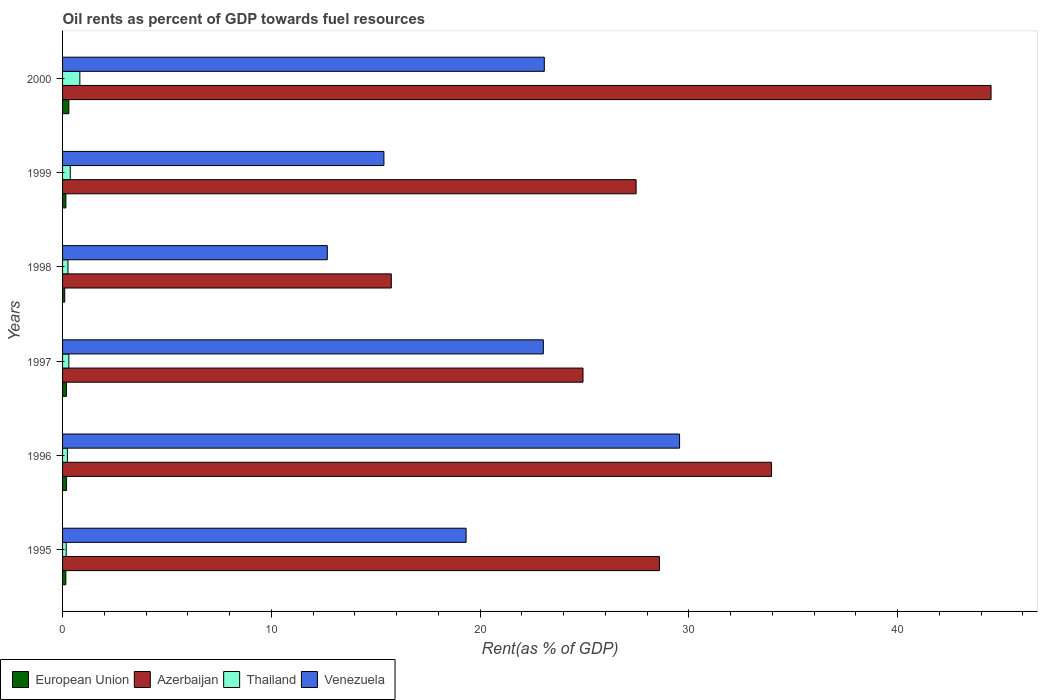How many different coloured bars are there?
Your answer should be compact. 4. How many bars are there on the 4th tick from the bottom?
Your answer should be very brief. 4. What is the label of the 6th group of bars from the top?
Keep it short and to the point. 1995. In how many cases, is the number of bars for a given year not equal to the number of legend labels?
Give a very brief answer. 0. What is the oil rent in European Union in 1997?
Offer a terse response. 0.19. Across all years, what is the maximum oil rent in Venezuela?
Offer a terse response. 29.55. Across all years, what is the minimum oil rent in Venezuela?
Provide a short and direct response. 12.68. In which year was the oil rent in Venezuela minimum?
Give a very brief answer. 1998. What is the total oil rent in Thailand in the graph?
Your answer should be compact. 2.16. What is the difference between the oil rent in Venezuela in 1996 and that in 2000?
Ensure brevity in your answer.  6.48. What is the difference between the oil rent in Venezuela in 2000 and the oil rent in Thailand in 1995?
Ensure brevity in your answer.  22.9. What is the average oil rent in Venezuela per year?
Offer a very short reply. 20.51. In the year 1996, what is the difference between the oil rent in Azerbaijan and oil rent in European Union?
Your answer should be very brief. 33.77. What is the ratio of the oil rent in Thailand in 1997 to that in 1999?
Give a very brief answer. 0.82. Is the oil rent in Azerbaijan in 1996 less than that in 1997?
Provide a succinct answer. No. Is the difference between the oil rent in Azerbaijan in 1995 and 1996 greater than the difference between the oil rent in European Union in 1995 and 1996?
Your answer should be compact. No. What is the difference between the highest and the second highest oil rent in Venezuela?
Give a very brief answer. 6.48. What is the difference between the highest and the lowest oil rent in European Union?
Your answer should be very brief. 0.2. Is it the case that in every year, the sum of the oil rent in Azerbaijan and oil rent in European Union is greater than the sum of oil rent in Venezuela and oil rent in Thailand?
Ensure brevity in your answer.  Yes. What does the 3rd bar from the top in 1999 represents?
Your answer should be compact. Azerbaijan. What does the 1st bar from the bottom in 1997 represents?
Provide a succinct answer. European Union. Is it the case that in every year, the sum of the oil rent in European Union and oil rent in Venezuela is greater than the oil rent in Thailand?
Your answer should be very brief. Yes. Are all the bars in the graph horizontal?
Keep it short and to the point. Yes. How many years are there in the graph?
Make the answer very short. 6. What is the difference between two consecutive major ticks on the X-axis?
Ensure brevity in your answer.  10. Are the values on the major ticks of X-axis written in scientific E-notation?
Ensure brevity in your answer.  No. Where does the legend appear in the graph?
Make the answer very short. Bottom left. What is the title of the graph?
Keep it short and to the point. Oil rents as percent of GDP towards fuel resources. Does "Fragile and conflict affected situations" appear as one of the legend labels in the graph?
Give a very brief answer. No. What is the label or title of the X-axis?
Provide a short and direct response. Rent(as % of GDP). What is the Rent(as % of GDP) in European Union in 1995?
Provide a succinct answer. 0.16. What is the Rent(as % of GDP) of Azerbaijan in 1995?
Offer a very short reply. 28.59. What is the Rent(as % of GDP) in Thailand in 1995?
Offer a terse response. 0.18. What is the Rent(as % of GDP) of Venezuela in 1995?
Your response must be concise. 19.33. What is the Rent(as % of GDP) of European Union in 1996?
Give a very brief answer. 0.19. What is the Rent(as % of GDP) in Azerbaijan in 1996?
Your answer should be compact. 33.96. What is the Rent(as % of GDP) of Thailand in 1996?
Your answer should be very brief. 0.23. What is the Rent(as % of GDP) in Venezuela in 1996?
Your answer should be very brief. 29.55. What is the Rent(as % of GDP) in European Union in 1997?
Give a very brief answer. 0.19. What is the Rent(as % of GDP) in Azerbaijan in 1997?
Provide a short and direct response. 24.93. What is the Rent(as % of GDP) of Thailand in 1997?
Ensure brevity in your answer.  0.3. What is the Rent(as % of GDP) of Venezuela in 1997?
Your answer should be very brief. 23.03. What is the Rent(as % of GDP) of European Union in 1998?
Offer a terse response. 0.1. What is the Rent(as % of GDP) in Azerbaijan in 1998?
Your answer should be very brief. 15.75. What is the Rent(as % of GDP) in Thailand in 1998?
Give a very brief answer. 0.26. What is the Rent(as % of GDP) in Venezuela in 1998?
Offer a very short reply. 12.68. What is the Rent(as % of GDP) in European Union in 1999?
Provide a succinct answer. 0.16. What is the Rent(as % of GDP) in Azerbaijan in 1999?
Provide a short and direct response. 27.47. What is the Rent(as % of GDP) of Thailand in 1999?
Provide a short and direct response. 0.37. What is the Rent(as % of GDP) in Venezuela in 1999?
Offer a very short reply. 15.39. What is the Rent(as % of GDP) in European Union in 2000?
Provide a succinct answer. 0.3. What is the Rent(as % of GDP) in Azerbaijan in 2000?
Keep it short and to the point. 44.47. What is the Rent(as % of GDP) of Thailand in 2000?
Ensure brevity in your answer.  0.83. What is the Rent(as % of GDP) in Venezuela in 2000?
Your answer should be compact. 23.07. Across all years, what is the maximum Rent(as % of GDP) in European Union?
Keep it short and to the point. 0.3. Across all years, what is the maximum Rent(as % of GDP) in Azerbaijan?
Keep it short and to the point. 44.47. Across all years, what is the maximum Rent(as % of GDP) of Thailand?
Your answer should be very brief. 0.83. Across all years, what is the maximum Rent(as % of GDP) of Venezuela?
Your answer should be very brief. 29.55. Across all years, what is the minimum Rent(as % of GDP) in European Union?
Offer a very short reply. 0.1. Across all years, what is the minimum Rent(as % of GDP) in Azerbaijan?
Ensure brevity in your answer.  15.75. Across all years, what is the minimum Rent(as % of GDP) in Thailand?
Offer a very short reply. 0.18. Across all years, what is the minimum Rent(as % of GDP) of Venezuela?
Your response must be concise. 12.68. What is the total Rent(as % of GDP) of European Union in the graph?
Offer a very short reply. 1.1. What is the total Rent(as % of GDP) of Azerbaijan in the graph?
Provide a short and direct response. 175.17. What is the total Rent(as % of GDP) in Thailand in the graph?
Give a very brief answer. 2.16. What is the total Rent(as % of GDP) of Venezuela in the graph?
Ensure brevity in your answer.  123.06. What is the difference between the Rent(as % of GDP) of European Union in 1995 and that in 1996?
Keep it short and to the point. -0.03. What is the difference between the Rent(as % of GDP) in Azerbaijan in 1995 and that in 1996?
Provide a short and direct response. -5.37. What is the difference between the Rent(as % of GDP) in Thailand in 1995 and that in 1996?
Ensure brevity in your answer.  -0.05. What is the difference between the Rent(as % of GDP) of Venezuela in 1995 and that in 1996?
Keep it short and to the point. -10.23. What is the difference between the Rent(as % of GDP) in European Union in 1995 and that in 1997?
Give a very brief answer. -0.03. What is the difference between the Rent(as % of GDP) in Azerbaijan in 1995 and that in 1997?
Provide a succinct answer. 3.66. What is the difference between the Rent(as % of GDP) in Thailand in 1995 and that in 1997?
Provide a succinct answer. -0.13. What is the difference between the Rent(as % of GDP) in Venezuela in 1995 and that in 1997?
Provide a short and direct response. -3.7. What is the difference between the Rent(as % of GDP) in European Union in 1995 and that in 1998?
Your answer should be compact. 0.05. What is the difference between the Rent(as % of GDP) of Azerbaijan in 1995 and that in 1998?
Offer a terse response. 12.84. What is the difference between the Rent(as % of GDP) in Thailand in 1995 and that in 1998?
Your answer should be compact. -0.08. What is the difference between the Rent(as % of GDP) of Venezuela in 1995 and that in 1998?
Provide a succinct answer. 6.65. What is the difference between the Rent(as % of GDP) in European Union in 1995 and that in 1999?
Provide a succinct answer. -0. What is the difference between the Rent(as % of GDP) of Azerbaijan in 1995 and that in 1999?
Your answer should be compact. 1.12. What is the difference between the Rent(as % of GDP) of Thailand in 1995 and that in 1999?
Give a very brief answer. -0.19. What is the difference between the Rent(as % of GDP) of Venezuela in 1995 and that in 1999?
Offer a very short reply. 3.94. What is the difference between the Rent(as % of GDP) in European Union in 1995 and that in 2000?
Your answer should be compact. -0.14. What is the difference between the Rent(as % of GDP) of Azerbaijan in 1995 and that in 2000?
Ensure brevity in your answer.  -15.89. What is the difference between the Rent(as % of GDP) in Thailand in 1995 and that in 2000?
Make the answer very short. -0.65. What is the difference between the Rent(as % of GDP) of Venezuela in 1995 and that in 2000?
Make the answer very short. -3.75. What is the difference between the Rent(as % of GDP) of European Union in 1996 and that in 1997?
Keep it short and to the point. 0. What is the difference between the Rent(as % of GDP) of Azerbaijan in 1996 and that in 1997?
Your answer should be very brief. 9.03. What is the difference between the Rent(as % of GDP) in Thailand in 1996 and that in 1997?
Your answer should be compact. -0.07. What is the difference between the Rent(as % of GDP) of Venezuela in 1996 and that in 1997?
Your answer should be very brief. 6.53. What is the difference between the Rent(as % of GDP) in European Union in 1996 and that in 1998?
Provide a short and direct response. 0.09. What is the difference between the Rent(as % of GDP) of Azerbaijan in 1996 and that in 1998?
Give a very brief answer. 18.21. What is the difference between the Rent(as % of GDP) in Thailand in 1996 and that in 1998?
Your response must be concise. -0.03. What is the difference between the Rent(as % of GDP) of Venezuela in 1996 and that in 1998?
Give a very brief answer. 16.87. What is the difference between the Rent(as % of GDP) of European Union in 1996 and that in 1999?
Offer a very short reply. 0.03. What is the difference between the Rent(as % of GDP) of Azerbaijan in 1996 and that in 1999?
Your response must be concise. 6.49. What is the difference between the Rent(as % of GDP) in Thailand in 1996 and that in 1999?
Offer a very short reply. -0.14. What is the difference between the Rent(as % of GDP) in Venezuela in 1996 and that in 1999?
Make the answer very short. 14.16. What is the difference between the Rent(as % of GDP) in European Union in 1996 and that in 2000?
Keep it short and to the point. -0.11. What is the difference between the Rent(as % of GDP) in Azerbaijan in 1996 and that in 2000?
Provide a short and direct response. -10.52. What is the difference between the Rent(as % of GDP) in Thailand in 1996 and that in 2000?
Keep it short and to the point. -0.6. What is the difference between the Rent(as % of GDP) in Venezuela in 1996 and that in 2000?
Provide a short and direct response. 6.48. What is the difference between the Rent(as % of GDP) in European Union in 1997 and that in 1998?
Ensure brevity in your answer.  0.08. What is the difference between the Rent(as % of GDP) in Azerbaijan in 1997 and that in 1998?
Ensure brevity in your answer.  9.18. What is the difference between the Rent(as % of GDP) in Thailand in 1997 and that in 1998?
Give a very brief answer. 0.04. What is the difference between the Rent(as % of GDP) of Venezuela in 1997 and that in 1998?
Your response must be concise. 10.35. What is the difference between the Rent(as % of GDP) of European Union in 1997 and that in 1999?
Give a very brief answer. 0.03. What is the difference between the Rent(as % of GDP) of Azerbaijan in 1997 and that in 1999?
Give a very brief answer. -2.54. What is the difference between the Rent(as % of GDP) of Thailand in 1997 and that in 1999?
Your answer should be compact. -0.07. What is the difference between the Rent(as % of GDP) of Venezuela in 1997 and that in 1999?
Provide a short and direct response. 7.64. What is the difference between the Rent(as % of GDP) of European Union in 1997 and that in 2000?
Make the answer very short. -0.11. What is the difference between the Rent(as % of GDP) of Azerbaijan in 1997 and that in 2000?
Offer a very short reply. -19.55. What is the difference between the Rent(as % of GDP) of Thailand in 1997 and that in 2000?
Your response must be concise. -0.53. What is the difference between the Rent(as % of GDP) in Venezuela in 1997 and that in 2000?
Offer a very short reply. -0.05. What is the difference between the Rent(as % of GDP) in European Union in 1998 and that in 1999?
Your response must be concise. -0.06. What is the difference between the Rent(as % of GDP) of Azerbaijan in 1998 and that in 1999?
Ensure brevity in your answer.  -11.73. What is the difference between the Rent(as % of GDP) of Thailand in 1998 and that in 1999?
Make the answer very short. -0.11. What is the difference between the Rent(as % of GDP) of Venezuela in 1998 and that in 1999?
Make the answer very short. -2.71. What is the difference between the Rent(as % of GDP) of European Union in 1998 and that in 2000?
Your answer should be very brief. -0.2. What is the difference between the Rent(as % of GDP) of Azerbaijan in 1998 and that in 2000?
Offer a terse response. -28.73. What is the difference between the Rent(as % of GDP) of Thailand in 1998 and that in 2000?
Your response must be concise. -0.57. What is the difference between the Rent(as % of GDP) in Venezuela in 1998 and that in 2000?
Provide a short and direct response. -10.39. What is the difference between the Rent(as % of GDP) in European Union in 1999 and that in 2000?
Make the answer very short. -0.14. What is the difference between the Rent(as % of GDP) of Azerbaijan in 1999 and that in 2000?
Your answer should be compact. -17. What is the difference between the Rent(as % of GDP) in Thailand in 1999 and that in 2000?
Offer a terse response. -0.46. What is the difference between the Rent(as % of GDP) in Venezuela in 1999 and that in 2000?
Your answer should be compact. -7.68. What is the difference between the Rent(as % of GDP) in European Union in 1995 and the Rent(as % of GDP) in Azerbaijan in 1996?
Offer a terse response. -33.8. What is the difference between the Rent(as % of GDP) in European Union in 1995 and the Rent(as % of GDP) in Thailand in 1996?
Make the answer very short. -0.07. What is the difference between the Rent(as % of GDP) of European Union in 1995 and the Rent(as % of GDP) of Venezuela in 1996?
Make the answer very short. -29.4. What is the difference between the Rent(as % of GDP) of Azerbaijan in 1995 and the Rent(as % of GDP) of Thailand in 1996?
Offer a terse response. 28.36. What is the difference between the Rent(as % of GDP) in Azerbaijan in 1995 and the Rent(as % of GDP) in Venezuela in 1996?
Give a very brief answer. -0.97. What is the difference between the Rent(as % of GDP) in Thailand in 1995 and the Rent(as % of GDP) in Venezuela in 1996?
Offer a very short reply. -29.38. What is the difference between the Rent(as % of GDP) of European Union in 1995 and the Rent(as % of GDP) of Azerbaijan in 1997?
Ensure brevity in your answer.  -24.77. What is the difference between the Rent(as % of GDP) in European Union in 1995 and the Rent(as % of GDP) in Thailand in 1997?
Give a very brief answer. -0.14. What is the difference between the Rent(as % of GDP) in European Union in 1995 and the Rent(as % of GDP) in Venezuela in 1997?
Provide a succinct answer. -22.87. What is the difference between the Rent(as % of GDP) in Azerbaijan in 1995 and the Rent(as % of GDP) in Thailand in 1997?
Your answer should be very brief. 28.29. What is the difference between the Rent(as % of GDP) in Azerbaijan in 1995 and the Rent(as % of GDP) in Venezuela in 1997?
Your response must be concise. 5.56. What is the difference between the Rent(as % of GDP) in Thailand in 1995 and the Rent(as % of GDP) in Venezuela in 1997?
Ensure brevity in your answer.  -22.85. What is the difference between the Rent(as % of GDP) of European Union in 1995 and the Rent(as % of GDP) of Azerbaijan in 1998?
Keep it short and to the point. -15.59. What is the difference between the Rent(as % of GDP) in European Union in 1995 and the Rent(as % of GDP) in Thailand in 1998?
Make the answer very short. -0.1. What is the difference between the Rent(as % of GDP) of European Union in 1995 and the Rent(as % of GDP) of Venezuela in 1998?
Give a very brief answer. -12.52. What is the difference between the Rent(as % of GDP) in Azerbaijan in 1995 and the Rent(as % of GDP) in Thailand in 1998?
Offer a very short reply. 28.33. What is the difference between the Rent(as % of GDP) in Azerbaijan in 1995 and the Rent(as % of GDP) in Venezuela in 1998?
Give a very brief answer. 15.91. What is the difference between the Rent(as % of GDP) of Thailand in 1995 and the Rent(as % of GDP) of Venezuela in 1998?
Your response must be concise. -12.51. What is the difference between the Rent(as % of GDP) in European Union in 1995 and the Rent(as % of GDP) in Azerbaijan in 1999?
Your answer should be compact. -27.32. What is the difference between the Rent(as % of GDP) of European Union in 1995 and the Rent(as % of GDP) of Thailand in 1999?
Provide a short and direct response. -0.21. What is the difference between the Rent(as % of GDP) of European Union in 1995 and the Rent(as % of GDP) of Venezuela in 1999?
Make the answer very short. -15.23. What is the difference between the Rent(as % of GDP) in Azerbaijan in 1995 and the Rent(as % of GDP) in Thailand in 1999?
Your answer should be compact. 28.22. What is the difference between the Rent(as % of GDP) in Azerbaijan in 1995 and the Rent(as % of GDP) in Venezuela in 1999?
Ensure brevity in your answer.  13.2. What is the difference between the Rent(as % of GDP) in Thailand in 1995 and the Rent(as % of GDP) in Venezuela in 1999?
Your answer should be very brief. -15.22. What is the difference between the Rent(as % of GDP) in European Union in 1995 and the Rent(as % of GDP) in Azerbaijan in 2000?
Give a very brief answer. -44.32. What is the difference between the Rent(as % of GDP) of European Union in 1995 and the Rent(as % of GDP) of Thailand in 2000?
Provide a succinct answer. -0.67. What is the difference between the Rent(as % of GDP) in European Union in 1995 and the Rent(as % of GDP) in Venezuela in 2000?
Offer a very short reply. -22.92. What is the difference between the Rent(as % of GDP) in Azerbaijan in 1995 and the Rent(as % of GDP) in Thailand in 2000?
Your answer should be very brief. 27.76. What is the difference between the Rent(as % of GDP) in Azerbaijan in 1995 and the Rent(as % of GDP) in Venezuela in 2000?
Ensure brevity in your answer.  5.51. What is the difference between the Rent(as % of GDP) in Thailand in 1995 and the Rent(as % of GDP) in Venezuela in 2000?
Provide a succinct answer. -22.9. What is the difference between the Rent(as % of GDP) of European Union in 1996 and the Rent(as % of GDP) of Azerbaijan in 1997?
Your response must be concise. -24.74. What is the difference between the Rent(as % of GDP) in European Union in 1996 and the Rent(as % of GDP) in Thailand in 1997?
Offer a terse response. -0.11. What is the difference between the Rent(as % of GDP) in European Union in 1996 and the Rent(as % of GDP) in Venezuela in 1997?
Ensure brevity in your answer.  -22.84. What is the difference between the Rent(as % of GDP) in Azerbaijan in 1996 and the Rent(as % of GDP) in Thailand in 1997?
Your answer should be very brief. 33.66. What is the difference between the Rent(as % of GDP) of Azerbaijan in 1996 and the Rent(as % of GDP) of Venezuela in 1997?
Your answer should be very brief. 10.93. What is the difference between the Rent(as % of GDP) of Thailand in 1996 and the Rent(as % of GDP) of Venezuela in 1997?
Your answer should be very brief. -22.8. What is the difference between the Rent(as % of GDP) of European Union in 1996 and the Rent(as % of GDP) of Azerbaijan in 1998?
Provide a short and direct response. -15.56. What is the difference between the Rent(as % of GDP) in European Union in 1996 and the Rent(as % of GDP) in Thailand in 1998?
Provide a short and direct response. -0.07. What is the difference between the Rent(as % of GDP) of European Union in 1996 and the Rent(as % of GDP) of Venezuela in 1998?
Give a very brief answer. -12.49. What is the difference between the Rent(as % of GDP) in Azerbaijan in 1996 and the Rent(as % of GDP) in Thailand in 1998?
Make the answer very short. 33.7. What is the difference between the Rent(as % of GDP) in Azerbaijan in 1996 and the Rent(as % of GDP) in Venezuela in 1998?
Keep it short and to the point. 21.28. What is the difference between the Rent(as % of GDP) in Thailand in 1996 and the Rent(as % of GDP) in Venezuela in 1998?
Provide a succinct answer. -12.45. What is the difference between the Rent(as % of GDP) in European Union in 1996 and the Rent(as % of GDP) in Azerbaijan in 1999?
Ensure brevity in your answer.  -27.28. What is the difference between the Rent(as % of GDP) of European Union in 1996 and the Rent(as % of GDP) of Thailand in 1999?
Your answer should be very brief. -0.18. What is the difference between the Rent(as % of GDP) of European Union in 1996 and the Rent(as % of GDP) of Venezuela in 1999?
Offer a very short reply. -15.2. What is the difference between the Rent(as % of GDP) in Azerbaijan in 1996 and the Rent(as % of GDP) in Thailand in 1999?
Ensure brevity in your answer.  33.59. What is the difference between the Rent(as % of GDP) of Azerbaijan in 1996 and the Rent(as % of GDP) of Venezuela in 1999?
Your response must be concise. 18.57. What is the difference between the Rent(as % of GDP) of Thailand in 1996 and the Rent(as % of GDP) of Venezuela in 1999?
Provide a succinct answer. -15.16. What is the difference between the Rent(as % of GDP) in European Union in 1996 and the Rent(as % of GDP) in Azerbaijan in 2000?
Provide a short and direct response. -44.28. What is the difference between the Rent(as % of GDP) in European Union in 1996 and the Rent(as % of GDP) in Thailand in 2000?
Give a very brief answer. -0.64. What is the difference between the Rent(as % of GDP) of European Union in 1996 and the Rent(as % of GDP) of Venezuela in 2000?
Your answer should be compact. -22.88. What is the difference between the Rent(as % of GDP) in Azerbaijan in 1996 and the Rent(as % of GDP) in Thailand in 2000?
Your response must be concise. 33.13. What is the difference between the Rent(as % of GDP) in Azerbaijan in 1996 and the Rent(as % of GDP) in Venezuela in 2000?
Provide a short and direct response. 10.88. What is the difference between the Rent(as % of GDP) in Thailand in 1996 and the Rent(as % of GDP) in Venezuela in 2000?
Keep it short and to the point. -22.84. What is the difference between the Rent(as % of GDP) in European Union in 1997 and the Rent(as % of GDP) in Azerbaijan in 1998?
Make the answer very short. -15.56. What is the difference between the Rent(as % of GDP) of European Union in 1997 and the Rent(as % of GDP) of Thailand in 1998?
Ensure brevity in your answer.  -0.07. What is the difference between the Rent(as % of GDP) in European Union in 1997 and the Rent(as % of GDP) in Venezuela in 1998?
Provide a succinct answer. -12.49. What is the difference between the Rent(as % of GDP) of Azerbaijan in 1997 and the Rent(as % of GDP) of Thailand in 1998?
Offer a terse response. 24.67. What is the difference between the Rent(as % of GDP) in Azerbaijan in 1997 and the Rent(as % of GDP) in Venezuela in 1998?
Your answer should be compact. 12.25. What is the difference between the Rent(as % of GDP) of Thailand in 1997 and the Rent(as % of GDP) of Venezuela in 1998?
Provide a succinct answer. -12.38. What is the difference between the Rent(as % of GDP) in European Union in 1997 and the Rent(as % of GDP) in Azerbaijan in 1999?
Offer a very short reply. -27.29. What is the difference between the Rent(as % of GDP) of European Union in 1997 and the Rent(as % of GDP) of Thailand in 1999?
Your answer should be very brief. -0.18. What is the difference between the Rent(as % of GDP) in European Union in 1997 and the Rent(as % of GDP) in Venezuela in 1999?
Provide a succinct answer. -15.21. What is the difference between the Rent(as % of GDP) of Azerbaijan in 1997 and the Rent(as % of GDP) of Thailand in 1999?
Offer a terse response. 24.56. What is the difference between the Rent(as % of GDP) of Azerbaijan in 1997 and the Rent(as % of GDP) of Venezuela in 1999?
Offer a very short reply. 9.54. What is the difference between the Rent(as % of GDP) in Thailand in 1997 and the Rent(as % of GDP) in Venezuela in 1999?
Give a very brief answer. -15.09. What is the difference between the Rent(as % of GDP) of European Union in 1997 and the Rent(as % of GDP) of Azerbaijan in 2000?
Your response must be concise. -44.29. What is the difference between the Rent(as % of GDP) in European Union in 1997 and the Rent(as % of GDP) in Thailand in 2000?
Make the answer very short. -0.64. What is the difference between the Rent(as % of GDP) in European Union in 1997 and the Rent(as % of GDP) in Venezuela in 2000?
Ensure brevity in your answer.  -22.89. What is the difference between the Rent(as % of GDP) of Azerbaijan in 1997 and the Rent(as % of GDP) of Thailand in 2000?
Make the answer very short. 24.1. What is the difference between the Rent(as % of GDP) of Azerbaijan in 1997 and the Rent(as % of GDP) of Venezuela in 2000?
Your answer should be very brief. 1.85. What is the difference between the Rent(as % of GDP) in Thailand in 1997 and the Rent(as % of GDP) in Venezuela in 2000?
Give a very brief answer. -22.77. What is the difference between the Rent(as % of GDP) of European Union in 1998 and the Rent(as % of GDP) of Azerbaijan in 1999?
Your response must be concise. -27.37. What is the difference between the Rent(as % of GDP) of European Union in 1998 and the Rent(as % of GDP) of Thailand in 1999?
Keep it short and to the point. -0.26. What is the difference between the Rent(as % of GDP) of European Union in 1998 and the Rent(as % of GDP) of Venezuela in 1999?
Ensure brevity in your answer.  -15.29. What is the difference between the Rent(as % of GDP) of Azerbaijan in 1998 and the Rent(as % of GDP) of Thailand in 1999?
Your response must be concise. 15.38. What is the difference between the Rent(as % of GDP) in Azerbaijan in 1998 and the Rent(as % of GDP) in Venezuela in 1999?
Ensure brevity in your answer.  0.35. What is the difference between the Rent(as % of GDP) of Thailand in 1998 and the Rent(as % of GDP) of Venezuela in 1999?
Offer a terse response. -15.13. What is the difference between the Rent(as % of GDP) of European Union in 1998 and the Rent(as % of GDP) of Azerbaijan in 2000?
Make the answer very short. -44.37. What is the difference between the Rent(as % of GDP) of European Union in 1998 and the Rent(as % of GDP) of Thailand in 2000?
Give a very brief answer. -0.72. What is the difference between the Rent(as % of GDP) in European Union in 1998 and the Rent(as % of GDP) in Venezuela in 2000?
Offer a terse response. -22.97. What is the difference between the Rent(as % of GDP) of Azerbaijan in 1998 and the Rent(as % of GDP) of Thailand in 2000?
Provide a short and direct response. 14.92. What is the difference between the Rent(as % of GDP) of Azerbaijan in 1998 and the Rent(as % of GDP) of Venezuela in 2000?
Make the answer very short. -7.33. What is the difference between the Rent(as % of GDP) of Thailand in 1998 and the Rent(as % of GDP) of Venezuela in 2000?
Provide a succinct answer. -22.82. What is the difference between the Rent(as % of GDP) in European Union in 1999 and the Rent(as % of GDP) in Azerbaijan in 2000?
Offer a very short reply. -44.31. What is the difference between the Rent(as % of GDP) of European Union in 1999 and the Rent(as % of GDP) of Thailand in 2000?
Make the answer very short. -0.67. What is the difference between the Rent(as % of GDP) in European Union in 1999 and the Rent(as % of GDP) in Venezuela in 2000?
Give a very brief answer. -22.92. What is the difference between the Rent(as % of GDP) of Azerbaijan in 1999 and the Rent(as % of GDP) of Thailand in 2000?
Offer a very short reply. 26.64. What is the difference between the Rent(as % of GDP) of Azerbaijan in 1999 and the Rent(as % of GDP) of Venezuela in 2000?
Give a very brief answer. 4.4. What is the difference between the Rent(as % of GDP) in Thailand in 1999 and the Rent(as % of GDP) in Venezuela in 2000?
Ensure brevity in your answer.  -22.71. What is the average Rent(as % of GDP) in European Union per year?
Provide a short and direct response. 0.18. What is the average Rent(as % of GDP) of Azerbaijan per year?
Ensure brevity in your answer.  29.19. What is the average Rent(as % of GDP) in Thailand per year?
Give a very brief answer. 0.36. What is the average Rent(as % of GDP) of Venezuela per year?
Offer a terse response. 20.51. In the year 1995, what is the difference between the Rent(as % of GDP) in European Union and Rent(as % of GDP) in Azerbaijan?
Offer a terse response. -28.43. In the year 1995, what is the difference between the Rent(as % of GDP) of European Union and Rent(as % of GDP) of Thailand?
Give a very brief answer. -0.02. In the year 1995, what is the difference between the Rent(as % of GDP) in European Union and Rent(as % of GDP) in Venezuela?
Provide a short and direct response. -19.17. In the year 1995, what is the difference between the Rent(as % of GDP) in Azerbaijan and Rent(as % of GDP) in Thailand?
Keep it short and to the point. 28.41. In the year 1995, what is the difference between the Rent(as % of GDP) in Azerbaijan and Rent(as % of GDP) in Venezuela?
Provide a succinct answer. 9.26. In the year 1995, what is the difference between the Rent(as % of GDP) of Thailand and Rent(as % of GDP) of Venezuela?
Offer a terse response. -19.15. In the year 1996, what is the difference between the Rent(as % of GDP) of European Union and Rent(as % of GDP) of Azerbaijan?
Make the answer very short. -33.77. In the year 1996, what is the difference between the Rent(as % of GDP) in European Union and Rent(as % of GDP) in Thailand?
Make the answer very short. -0.04. In the year 1996, what is the difference between the Rent(as % of GDP) in European Union and Rent(as % of GDP) in Venezuela?
Offer a terse response. -29.36. In the year 1996, what is the difference between the Rent(as % of GDP) of Azerbaijan and Rent(as % of GDP) of Thailand?
Make the answer very short. 33.73. In the year 1996, what is the difference between the Rent(as % of GDP) of Azerbaijan and Rent(as % of GDP) of Venezuela?
Keep it short and to the point. 4.4. In the year 1996, what is the difference between the Rent(as % of GDP) in Thailand and Rent(as % of GDP) in Venezuela?
Give a very brief answer. -29.32. In the year 1997, what is the difference between the Rent(as % of GDP) of European Union and Rent(as % of GDP) of Azerbaijan?
Give a very brief answer. -24.74. In the year 1997, what is the difference between the Rent(as % of GDP) in European Union and Rent(as % of GDP) in Thailand?
Offer a terse response. -0.11. In the year 1997, what is the difference between the Rent(as % of GDP) in European Union and Rent(as % of GDP) in Venezuela?
Offer a terse response. -22.84. In the year 1997, what is the difference between the Rent(as % of GDP) in Azerbaijan and Rent(as % of GDP) in Thailand?
Provide a short and direct response. 24.63. In the year 1997, what is the difference between the Rent(as % of GDP) in Azerbaijan and Rent(as % of GDP) in Venezuela?
Keep it short and to the point. 1.9. In the year 1997, what is the difference between the Rent(as % of GDP) in Thailand and Rent(as % of GDP) in Venezuela?
Provide a short and direct response. -22.73. In the year 1998, what is the difference between the Rent(as % of GDP) in European Union and Rent(as % of GDP) in Azerbaijan?
Your response must be concise. -15.64. In the year 1998, what is the difference between the Rent(as % of GDP) in European Union and Rent(as % of GDP) in Thailand?
Keep it short and to the point. -0.15. In the year 1998, what is the difference between the Rent(as % of GDP) of European Union and Rent(as % of GDP) of Venezuela?
Provide a short and direct response. -12.58. In the year 1998, what is the difference between the Rent(as % of GDP) of Azerbaijan and Rent(as % of GDP) of Thailand?
Your answer should be very brief. 15.49. In the year 1998, what is the difference between the Rent(as % of GDP) of Azerbaijan and Rent(as % of GDP) of Venezuela?
Your response must be concise. 3.07. In the year 1998, what is the difference between the Rent(as % of GDP) in Thailand and Rent(as % of GDP) in Venezuela?
Your answer should be very brief. -12.42. In the year 1999, what is the difference between the Rent(as % of GDP) of European Union and Rent(as % of GDP) of Azerbaijan?
Offer a terse response. -27.31. In the year 1999, what is the difference between the Rent(as % of GDP) in European Union and Rent(as % of GDP) in Thailand?
Provide a short and direct response. -0.21. In the year 1999, what is the difference between the Rent(as % of GDP) of European Union and Rent(as % of GDP) of Venezuela?
Provide a short and direct response. -15.23. In the year 1999, what is the difference between the Rent(as % of GDP) in Azerbaijan and Rent(as % of GDP) in Thailand?
Provide a short and direct response. 27.1. In the year 1999, what is the difference between the Rent(as % of GDP) of Azerbaijan and Rent(as % of GDP) of Venezuela?
Offer a very short reply. 12.08. In the year 1999, what is the difference between the Rent(as % of GDP) in Thailand and Rent(as % of GDP) in Venezuela?
Offer a terse response. -15.02. In the year 2000, what is the difference between the Rent(as % of GDP) in European Union and Rent(as % of GDP) in Azerbaijan?
Ensure brevity in your answer.  -44.17. In the year 2000, what is the difference between the Rent(as % of GDP) in European Union and Rent(as % of GDP) in Thailand?
Offer a terse response. -0.53. In the year 2000, what is the difference between the Rent(as % of GDP) in European Union and Rent(as % of GDP) in Venezuela?
Your answer should be very brief. -22.77. In the year 2000, what is the difference between the Rent(as % of GDP) in Azerbaijan and Rent(as % of GDP) in Thailand?
Your answer should be compact. 43.65. In the year 2000, what is the difference between the Rent(as % of GDP) in Azerbaijan and Rent(as % of GDP) in Venezuela?
Provide a short and direct response. 21.4. In the year 2000, what is the difference between the Rent(as % of GDP) in Thailand and Rent(as % of GDP) in Venezuela?
Your answer should be compact. -22.25. What is the ratio of the Rent(as % of GDP) in European Union in 1995 to that in 1996?
Ensure brevity in your answer.  0.82. What is the ratio of the Rent(as % of GDP) in Azerbaijan in 1995 to that in 1996?
Provide a succinct answer. 0.84. What is the ratio of the Rent(as % of GDP) of Thailand in 1995 to that in 1996?
Keep it short and to the point. 0.76. What is the ratio of the Rent(as % of GDP) of Venezuela in 1995 to that in 1996?
Ensure brevity in your answer.  0.65. What is the ratio of the Rent(as % of GDP) of European Union in 1995 to that in 1997?
Keep it short and to the point. 0.84. What is the ratio of the Rent(as % of GDP) in Azerbaijan in 1995 to that in 1997?
Offer a terse response. 1.15. What is the ratio of the Rent(as % of GDP) in Thailand in 1995 to that in 1997?
Provide a succinct answer. 0.58. What is the ratio of the Rent(as % of GDP) of Venezuela in 1995 to that in 1997?
Your answer should be very brief. 0.84. What is the ratio of the Rent(as % of GDP) of European Union in 1995 to that in 1998?
Provide a short and direct response. 1.52. What is the ratio of the Rent(as % of GDP) in Azerbaijan in 1995 to that in 1998?
Your answer should be compact. 1.82. What is the ratio of the Rent(as % of GDP) of Thailand in 1995 to that in 1998?
Provide a succinct answer. 0.68. What is the ratio of the Rent(as % of GDP) in Venezuela in 1995 to that in 1998?
Keep it short and to the point. 1.52. What is the ratio of the Rent(as % of GDP) in Azerbaijan in 1995 to that in 1999?
Offer a very short reply. 1.04. What is the ratio of the Rent(as % of GDP) of Thailand in 1995 to that in 1999?
Offer a very short reply. 0.48. What is the ratio of the Rent(as % of GDP) in Venezuela in 1995 to that in 1999?
Ensure brevity in your answer.  1.26. What is the ratio of the Rent(as % of GDP) of European Union in 1995 to that in 2000?
Keep it short and to the point. 0.52. What is the ratio of the Rent(as % of GDP) in Azerbaijan in 1995 to that in 2000?
Provide a succinct answer. 0.64. What is the ratio of the Rent(as % of GDP) of Thailand in 1995 to that in 2000?
Provide a succinct answer. 0.21. What is the ratio of the Rent(as % of GDP) of Venezuela in 1995 to that in 2000?
Provide a succinct answer. 0.84. What is the ratio of the Rent(as % of GDP) of European Union in 1996 to that in 1997?
Provide a short and direct response. 1.02. What is the ratio of the Rent(as % of GDP) of Azerbaijan in 1996 to that in 1997?
Offer a very short reply. 1.36. What is the ratio of the Rent(as % of GDP) in Thailand in 1996 to that in 1997?
Your answer should be very brief. 0.76. What is the ratio of the Rent(as % of GDP) of Venezuela in 1996 to that in 1997?
Offer a very short reply. 1.28. What is the ratio of the Rent(as % of GDP) of European Union in 1996 to that in 1998?
Make the answer very short. 1.85. What is the ratio of the Rent(as % of GDP) of Azerbaijan in 1996 to that in 1998?
Your answer should be very brief. 2.16. What is the ratio of the Rent(as % of GDP) of Thailand in 1996 to that in 1998?
Give a very brief answer. 0.89. What is the ratio of the Rent(as % of GDP) of Venezuela in 1996 to that in 1998?
Keep it short and to the point. 2.33. What is the ratio of the Rent(as % of GDP) in European Union in 1996 to that in 1999?
Keep it short and to the point. 1.2. What is the ratio of the Rent(as % of GDP) in Azerbaijan in 1996 to that in 1999?
Your answer should be very brief. 1.24. What is the ratio of the Rent(as % of GDP) in Thailand in 1996 to that in 1999?
Your answer should be compact. 0.63. What is the ratio of the Rent(as % of GDP) in Venezuela in 1996 to that in 1999?
Give a very brief answer. 1.92. What is the ratio of the Rent(as % of GDP) in European Union in 1996 to that in 2000?
Provide a short and direct response. 0.64. What is the ratio of the Rent(as % of GDP) in Azerbaijan in 1996 to that in 2000?
Provide a succinct answer. 0.76. What is the ratio of the Rent(as % of GDP) in Thailand in 1996 to that in 2000?
Your answer should be compact. 0.28. What is the ratio of the Rent(as % of GDP) of Venezuela in 1996 to that in 2000?
Make the answer very short. 1.28. What is the ratio of the Rent(as % of GDP) of European Union in 1997 to that in 1998?
Offer a terse response. 1.81. What is the ratio of the Rent(as % of GDP) of Azerbaijan in 1997 to that in 1998?
Provide a succinct answer. 1.58. What is the ratio of the Rent(as % of GDP) of Thailand in 1997 to that in 1998?
Offer a terse response. 1.17. What is the ratio of the Rent(as % of GDP) in Venezuela in 1997 to that in 1998?
Give a very brief answer. 1.82. What is the ratio of the Rent(as % of GDP) of European Union in 1997 to that in 1999?
Your answer should be compact. 1.18. What is the ratio of the Rent(as % of GDP) of Azerbaijan in 1997 to that in 1999?
Make the answer very short. 0.91. What is the ratio of the Rent(as % of GDP) in Thailand in 1997 to that in 1999?
Your answer should be very brief. 0.82. What is the ratio of the Rent(as % of GDP) of Venezuela in 1997 to that in 1999?
Offer a very short reply. 1.5. What is the ratio of the Rent(as % of GDP) in European Union in 1997 to that in 2000?
Your response must be concise. 0.62. What is the ratio of the Rent(as % of GDP) in Azerbaijan in 1997 to that in 2000?
Keep it short and to the point. 0.56. What is the ratio of the Rent(as % of GDP) of Thailand in 1997 to that in 2000?
Your answer should be very brief. 0.36. What is the ratio of the Rent(as % of GDP) in Venezuela in 1997 to that in 2000?
Make the answer very short. 1. What is the ratio of the Rent(as % of GDP) in European Union in 1998 to that in 1999?
Keep it short and to the point. 0.65. What is the ratio of the Rent(as % of GDP) in Azerbaijan in 1998 to that in 1999?
Make the answer very short. 0.57. What is the ratio of the Rent(as % of GDP) of Thailand in 1998 to that in 1999?
Your answer should be compact. 0.7. What is the ratio of the Rent(as % of GDP) of Venezuela in 1998 to that in 1999?
Offer a very short reply. 0.82. What is the ratio of the Rent(as % of GDP) of European Union in 1998 to that in 2000?
Your answer should be compact. 0.34. What is the ratio of the Rent(as % of GDP) of Azerbaijan in 1998 to that in 2000?
Keep it short and to the point. 0.35. What is the ratio of the Rent(as % of GDP) in Thailand in 1998 to that in 2000?
Ensure brevity in your answer.  0.31. What is the ratio of the Rent(as % of GDP) of Venezuela in 1998 to that in 2000?
Your response must be concise. 0.55. What is the ratio of the Rent(as % of GDP) of European Union in 1999 to that in 2000?
Offer a terse response. 0.53. What is the ratio of the Rent(as % of GDP) in Azerbaijan in 1999 to that in 2000?
Keep it short and to the point. 0.62. What is the ratio of the Rent(as % of GDP) in Thailand in 1999 to that in 2000?
Make the answer very short. 0.44. What is the ratio of the Rent(as % of GDP) of Venezuela in 1999 to that in 2000?
Offer a terse response. 0.67. What is the difference between the highest and the second highest Rent(as % of GDP) in European Union?
Offer a very short reply. 0.11. What is the difference between the highest and the second highest Rent(as % of GDP) in Azerbaijan?
Give a very brief answer. 10.52. What is the difference between the highest and the second highest Rent(as % of GDP) in Thailand?
Your answer should be compact. 0.46. What is the difference between the highest and the second highest Rent(as % of GDP) of Venezuela?
Provide a succinct answer. 6.48. What is the difference between the highest and the lowest Rent(as % of GDP) in European Union?
Your answer should be very brief. 0.2. What is the difference between the highest and the lowest Rent(as % of GDP) of Azerbaijan?
Make the answer very short. 28.73. What is the difference between the highest and the lowest Rent(as % of GDP) in Thailand?
Provide a succinct answer. 0.65. What is the difference between the highest and the lowest Rent(as % of GDP) of Venezuela?
Make the answer very short. 16.87. 